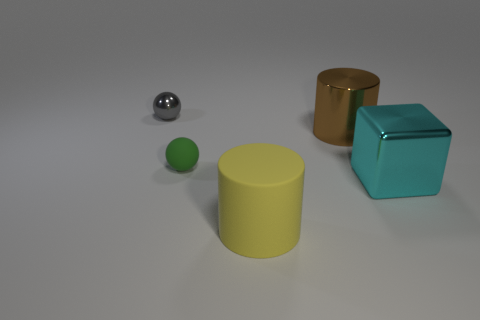Subtract all red spheres. Subtract all cyan cubes. How many spheres are left? 2 Add 3 tiny red metal spheres. How many objects exist? 8 Subtract all cubes. How many objects are left? 4 Subtract 0 red blocks. How many objects are left? 5 Subtract all cyan things. Subtract all small rubber things. How many objects are left? 3 Add 3 small green balls. How many small green balls are left? 4 Add 2 blue metallic spheres. How many blue metallic spheres exist? 2 